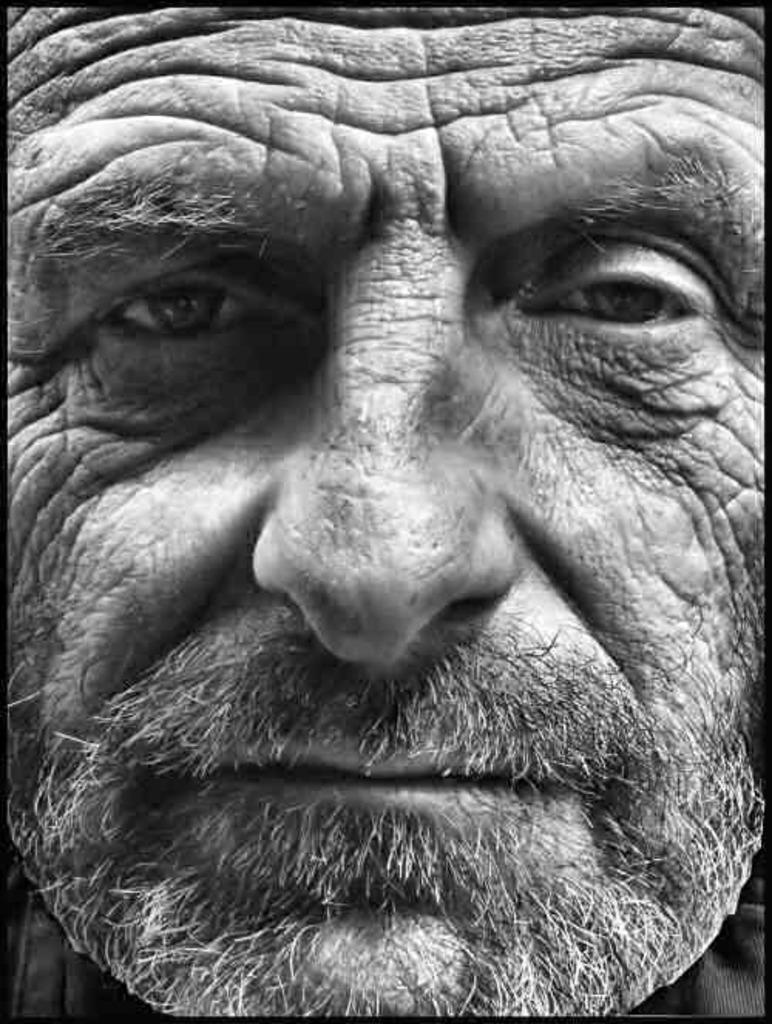What is present in the image? There is a man in the image. Can you describe the man's appearance? The man has a white beard and appears to be old. What type of support does the man need in the image? There is no indication in the image that the man needs any support. What kind of nerve can be seen in the image? There is no nerve present in the image; it features a man with a white beard and old age. 